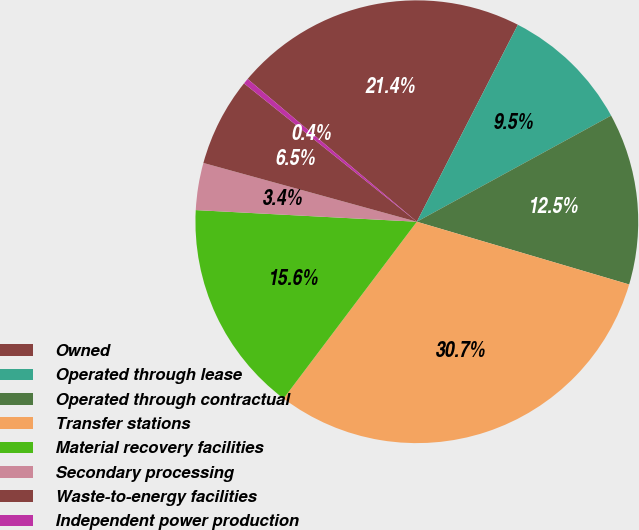Convert chart. <chart><loc_0><loc_0><loc_500><loc_500><pie_chart><fcel>Owned<fcel>Operated through lease<fcel>Operated through contractual<fcel>Transfer stations<fcel>Material recovery facilities<fcel>Secondary processing<fcel>Waste-to-energy facilities<fcel>Independent power production<nl><fcel>21.39%<fcel>9.5%<fcel>12.53%<fcel>30.71%<fcel>15.56%<fcel>3.44%<fcel>6.47%<fcel>0.41%<nl></chart> 